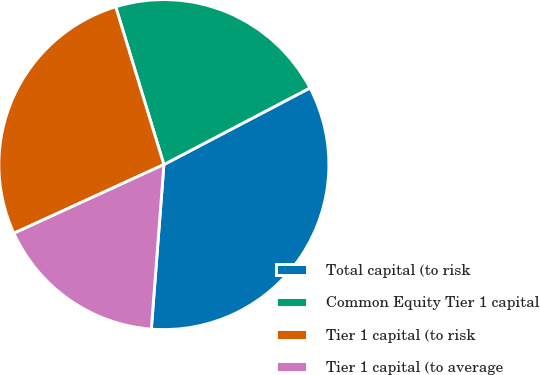Convert chart to OTSL. <chart><loc_0><loc_0><loc_500><loc_500><pie_chart><fcel>Total capital (to risk<fcel>Common Equity Tier 1 capital<fcel>Tier 1 capital (to risk<fcel>Tier 1 capital (to average<nl><fcel>33.9%<fcel>22.03%<fcel>27.12%<fcel>16.95%<nl></chart> 